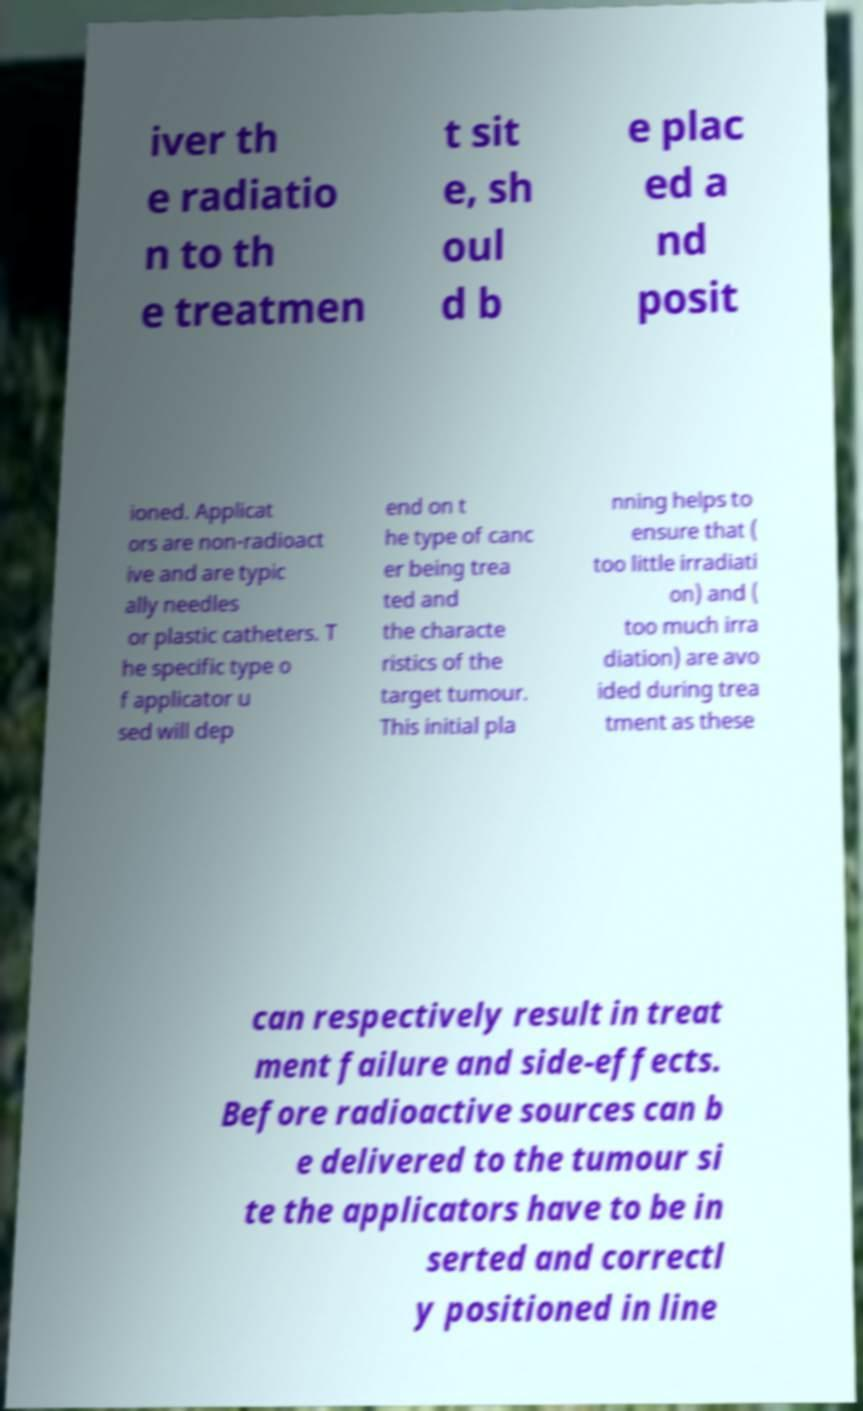Could you extract and type out the text from this image? iver th e radiatio n to th e treatmen t sit e, sh oul d b e plac ed a nd posit ioned. Applicat ors are non-radioact ive and are typic ally needles or plastic catheters. T he specific type o f applicator u sed will dep end on t he type of canc er being trea ted and the characte ristics of the target tumour. This initial pla nning helps to ensure that ( too little irradiati on) and ( too much irra diation) are avo ided during trea tment as these can respectively result in treat ment failure and side-effects. Before radioactive sources can b e delivered to the tumour si te the applicators have to be in serted and correctl y positioned in line 